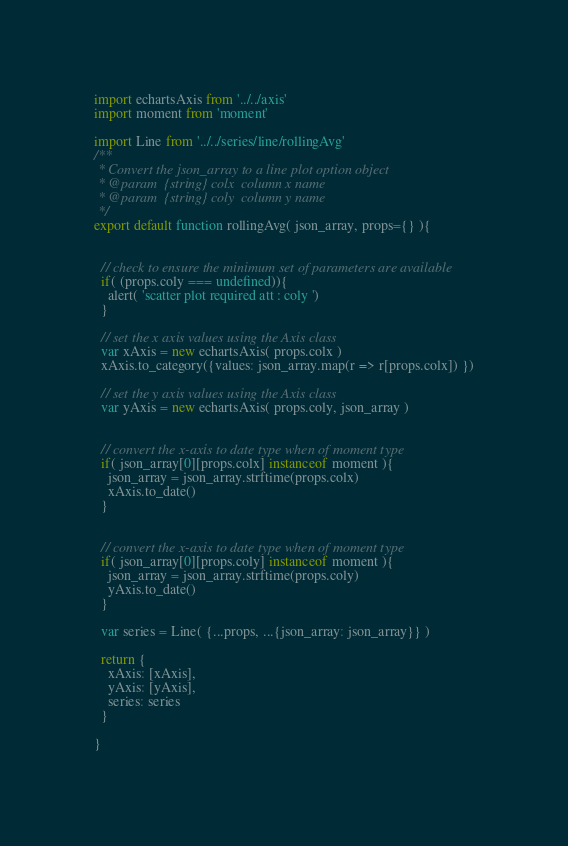Convert code to text. <code><loc_0><loc_0><loc_500><loc_500><_JavaScript_>

import echartsAxis from '../../axis'
import moment from 'moment'

import Line from '../../series/line/rollingAvg'
/**
 * Convert the json_array to a line plot option object
 * @param  {string} colx  column x name
 * @param  {string} coly  column y name
 */
export default function rollingAvg( json_array, props={} ){


  // check to ensure the minimum set of parameters are available
  if( (props.coly === undefined)){
    alert( 'scatter plot required att : coly ')
  }

  // set the x axis values using the Axis class
  var xAxis = new echartsAxis( props.colx )
  xAxis.to_category({values: json_array.map(r => r[props.colx]) })

  // set the y axis values using the Axis class
  var yAxis = new echartsAxis( props.coly, json_array )


  // convert the x-axis to date type when of moment type
  if( json_array[0][props.colx] instanceof moment ){
    json_array = json_array.strftime(props.colx)
    xAxis.to_date()
  }


  // convert the x-axis to date type when of moment type
  if( json_array[0][props.coly] instanceof moment ){
    json_array = json_array.strftime(props.coly)
    yAxis.to_date()
  }

  var series = Line( {...props, ...{json_array: json_array}} )

  return {
    xAxis: [xAxis],
    yAxis: [yAxis],
    series: series
  }

}
</code> 